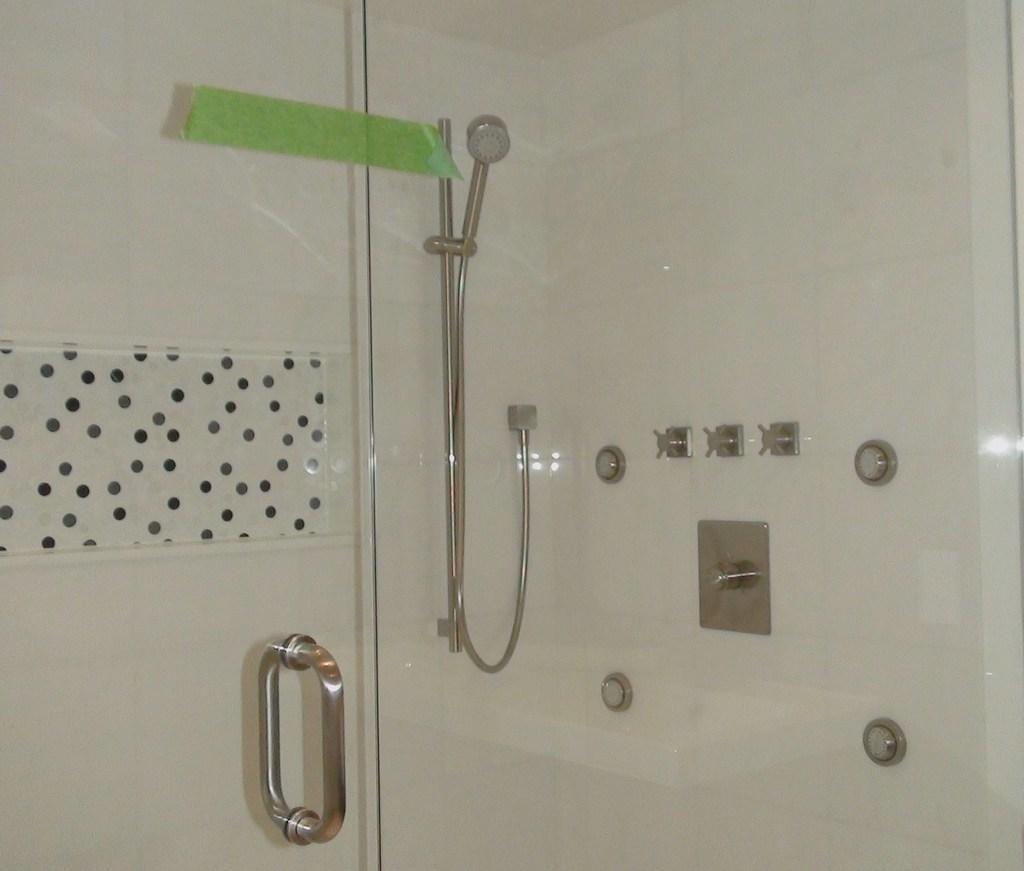How would you summarize this image in a sentence or two? In this picture we can observe a glass. There is a door handle fixed to the door. We can observe a shower. In the background there is a white color wall. 